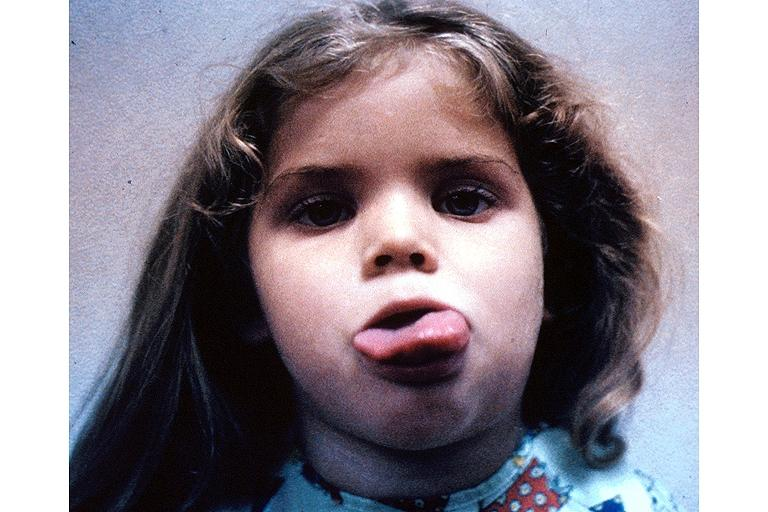what does this image show?
Answer the question using a single word or phrase. Neurofibromatosis-macroglossi 